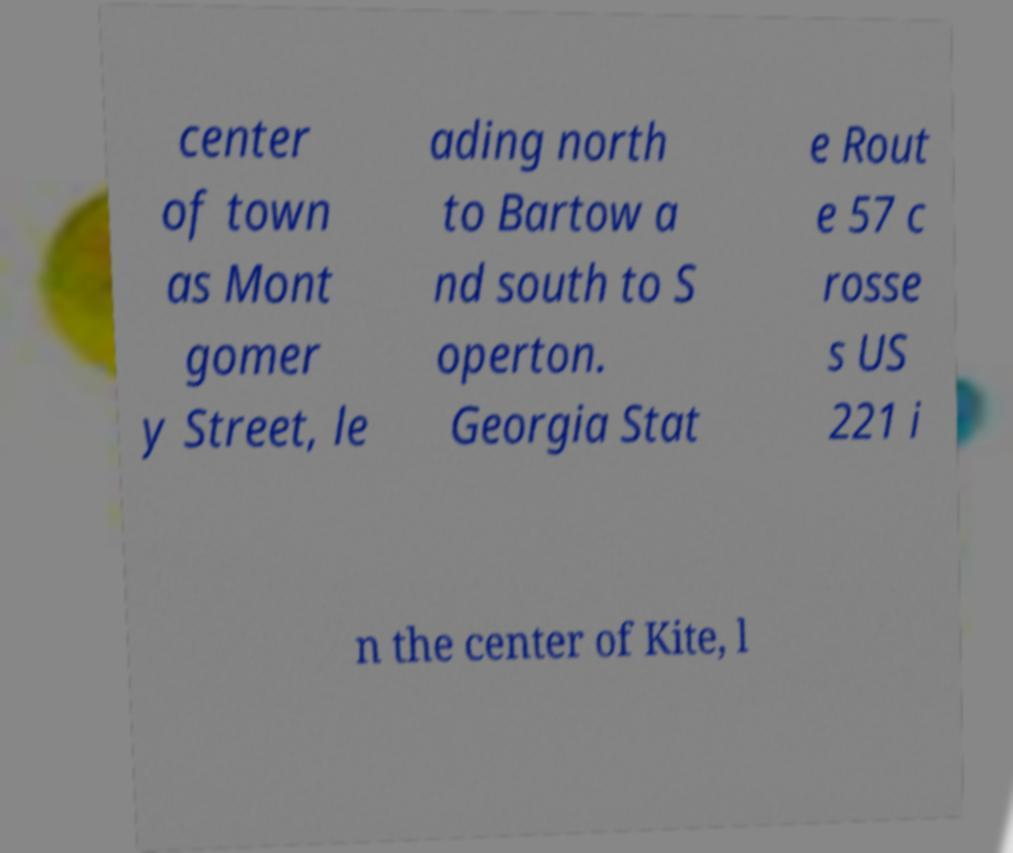Could you extract and type out the text from this image? center of town as Mont gomer y Street, le ading north to Bartow a nd south to S operton. Georgia Stat e Rout e 57 c rosse s US 221 i n the center of Kite, l 